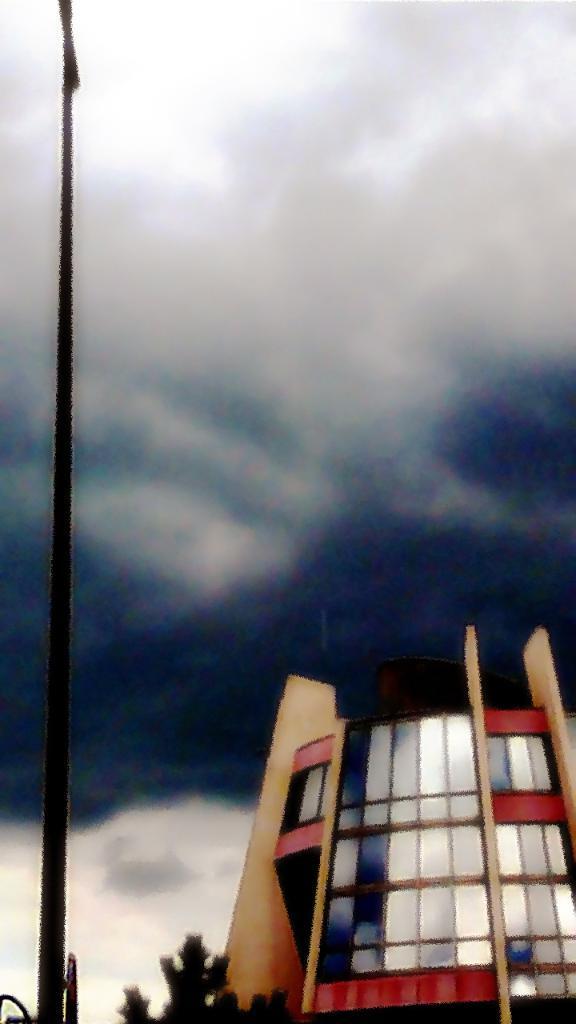In one or two sentences, can you explain what this image depicts? In this picture we can see a building on the right side, on the left side there is a pole, we can see a tree at the bottom, there is the sky at the top of the picture. 